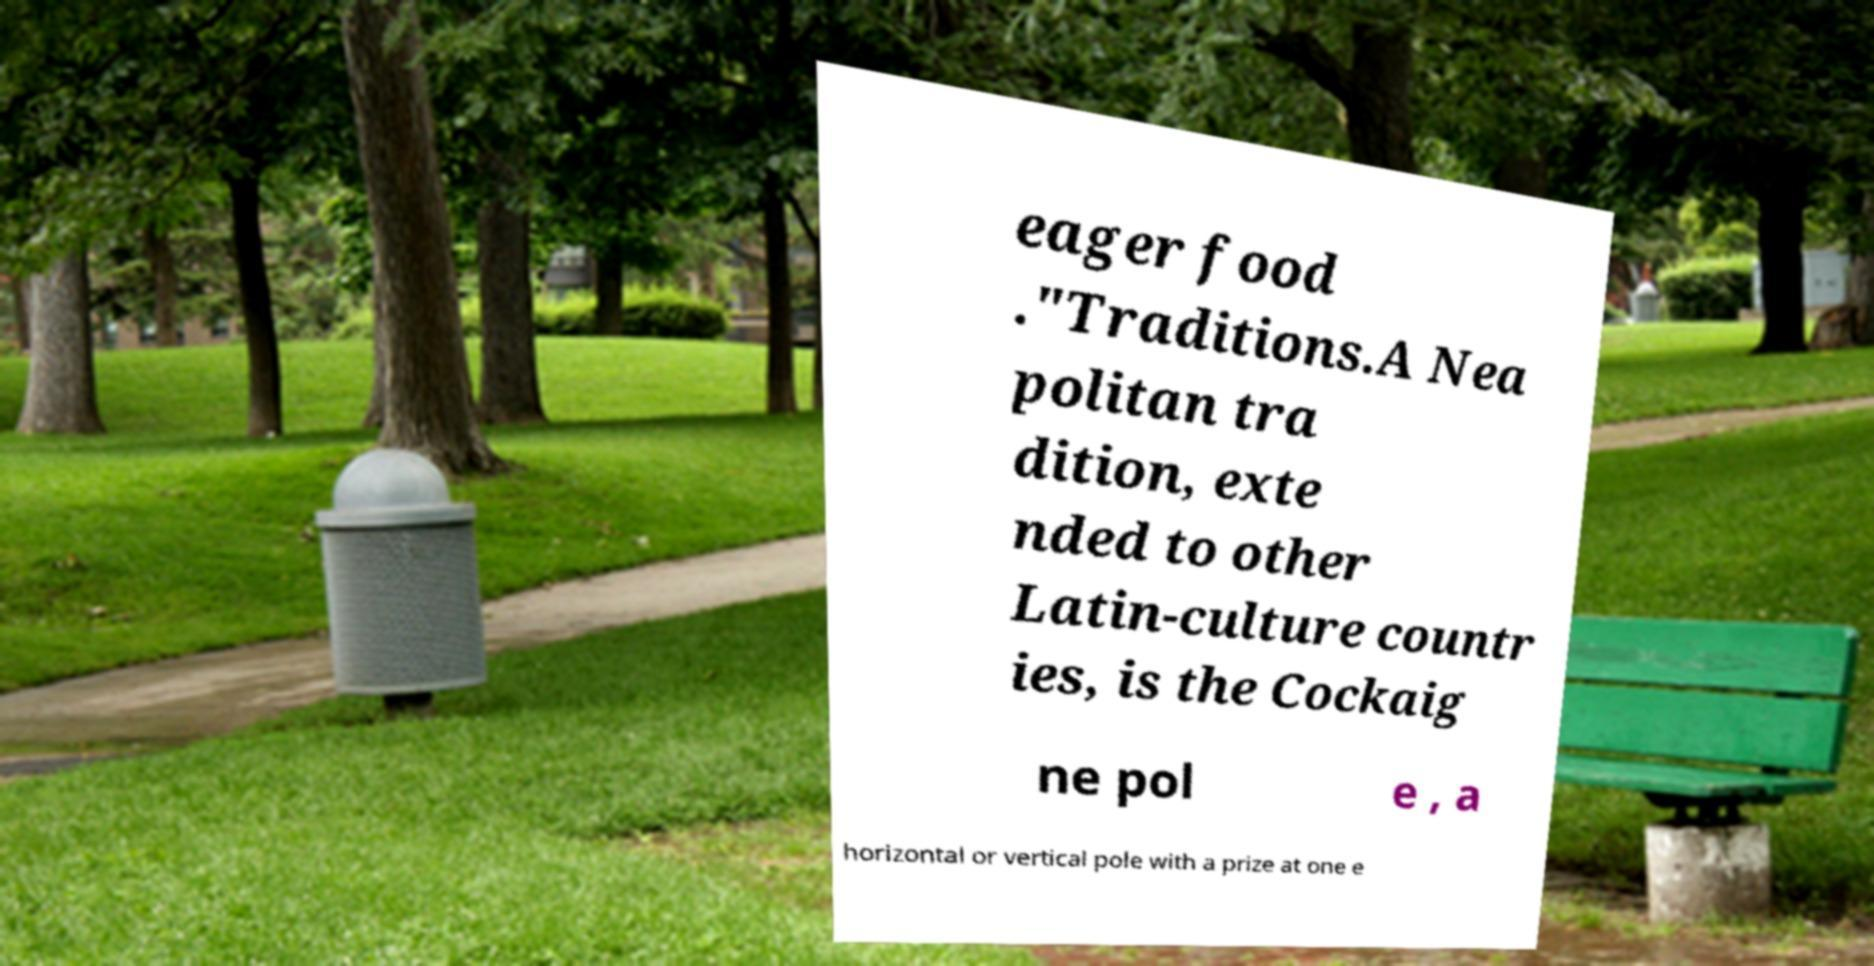Could you extract and type out the text from this image? eager food ."Traditions.A Nea politan tra dition, exte nded to other Latin-culture countr ies, is the Cockaig ne pol e , a horizontal or vertical pole with a prize at one e 